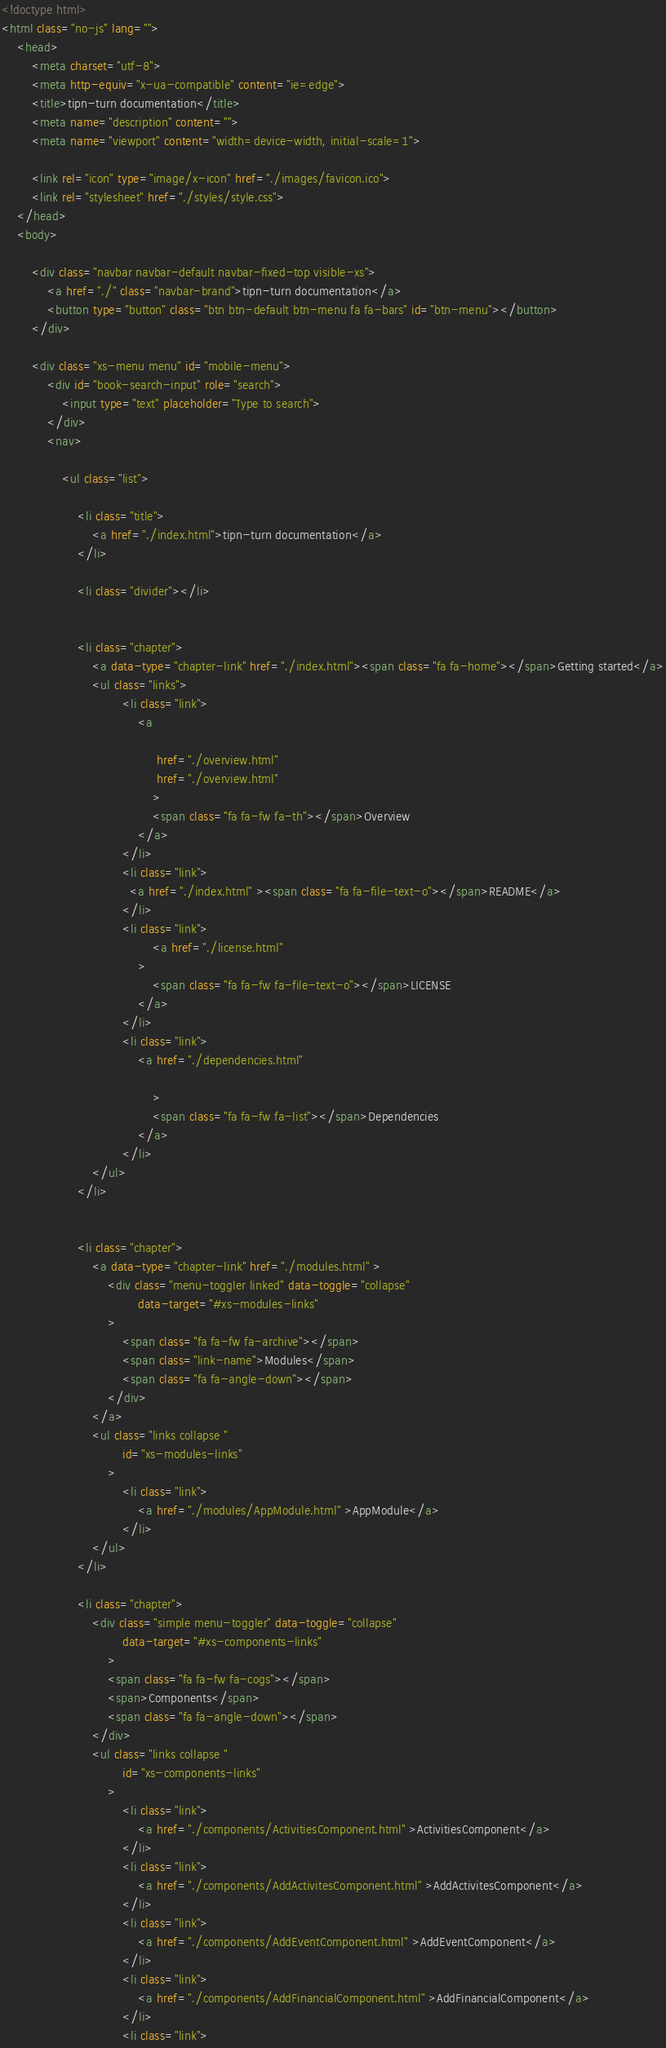Convert code to text. <code><loc_0><loc_0><loc_500><loc_500><_HTML_><!doctype html>
<html class="no-js" lang="">
    <head>
        <meta charset="utf-8">
        <meta http-equiv="x-ua-compatible" content="ie=edge">
        <title>tipn-turn documentation</title>
        <meta name="description" content="">
        <meta name="viewport" content="width=device-width, initial-scale=1">

        <link rel="icon" type="image/x-icon" href="./images/favicon.ico">
	    <link rel="stylesheet" href="./styles/style.css">
    </head>
    <body>

        <div class="navbar navbar-default navbar-fixed-top visible-xs">
            <a href="./" class="navbar-brand">tipn-turn documentation</a>
            <button type="button" class="btn btn-default btn-menu fa fa-bars" id="btn-menu"></button>
        </div>

        <div class="xs-menu menu" id="mobile-menu">
            <div id="book-search-input" role="search">
                <input type="text" placeholder="Type to search">
            </div>
            <nav>
            
                <ul class="list">
            
                    <li class="title">
                        <a href="./index.html">tipn-turn documentation</a>
                    </li>
            
                    <li class="divider"></li>
            
            
                    <li class="chapter">
                        <a data-type="chapter-link" href="./index.html"><span class="fa fa-home"></span>Getting started</a>
                        <ul class="links">
                                <li class="link">
                                    <a 
                                        
                                         href="./overview.html" 
                                         href="./overview.html" 
                                        >
                                        <span class="fa fa-fw fa-th"></span>Overview
                                    </a>
                                </li>
                                <li class="link">
                                  <a href="./index.html" ><span class="fa fa-file-text-o"></span>README</a>
                                </li>
                                <li class="link">
                                        <a href="./license.html"
                                    >
                                        <span class="fa fa-fw fa-file-text-o"></span>LICENSE
                                    </a>
                                </li>
                                <li class="link">
                                    <a href="./dependencies.html"
                                        
                                        >
                                        <span class="fa fa-fw fa-list"></span>Dependencies
                                    </a>
                                </li>
                        </ul>
                    </li>
            
            
                    <li class="chapter">
                        <a data-type="chapter-link" href="./modules.html" >
                            <div class="menu-toggler linked" data-toggle="collapse"
                                    data-target="#xs-modules-links"
                            >
                                <span class="fa fa-fw fa-archive"></span>
                                <span class="link-name">Modules</span>
                                <span class="fa fa-angle-down"></span>
                            </div>
                        </a>
                        <ul class="links collapse "
                                id="xs-modules-links"
                            >
                                <li class="link">
                                    <a href="./modules/AppModule.html" >AppModule</a>
                                </li>
                        </ul>
                    </li>
            
                    <li class="chapter">
                        <div class="simple menu-toggler" data-toggle="collapse"
                                data-target="#xs-components-links"
                            >
                            <span class="fa fa-fw fa-cogs"></span>
                            <span>Components</span>
                            <span class="fa fa-angle-down"></span>
                        </div>
                        <ul class="links collapse "
                                id="xs-components-links"
                            >
                                <li class="link">
                                    <a href="./components/ActivitiesComponent.html" >ActivitiesComponent</a>
                                </li>
                                <li class="link">
                                    <a href="./components/AddActivitesComponent.html" >AddActivitesComponent</a>
                                </li>
                                <li class="link">
                                    <a href="./components/AddEventComponent.html" >AddEventComponent</a>
                                </li>
                                <li class="link">
                                    <a href="./components/AddFinancialComponent.html" >AddFinancialComponent</a>
                                </li>
                                <li class="link"></code> 